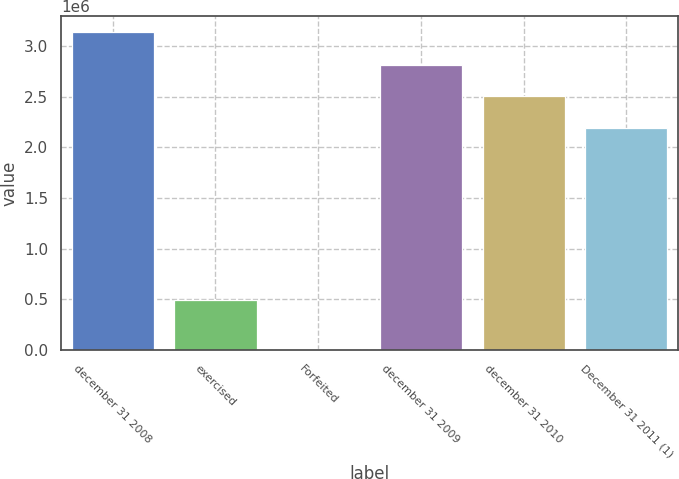Convert chart. <chart><loc_0><loc_0><loc_500><loc_500><bar_chart><fcel>december 31 2008<fcel>exercised<fcel>Forfeited<fcel>december 31 2009<fcel>december 31 2010<fcel>December 31 2011 (1)<nl><fcel>3.14052e+06<fcel>490617<fcel>8064<fcel>2.8174e+06<fcel>2.50415e+06<fcel>2.19091e+06<nl></chart> 